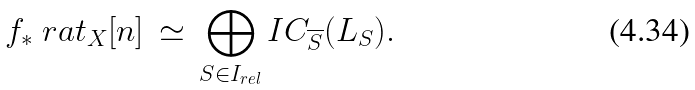<formula> <loc_0><loc_0><loc_500><loc_500>f _ { * } \ r a t _ { X } [ n ] \, \simeq \, \bigoplus _ { S \in I _ { r e l } } I C _ { \overline { S } } ( L _ { S } ) .</formula> 